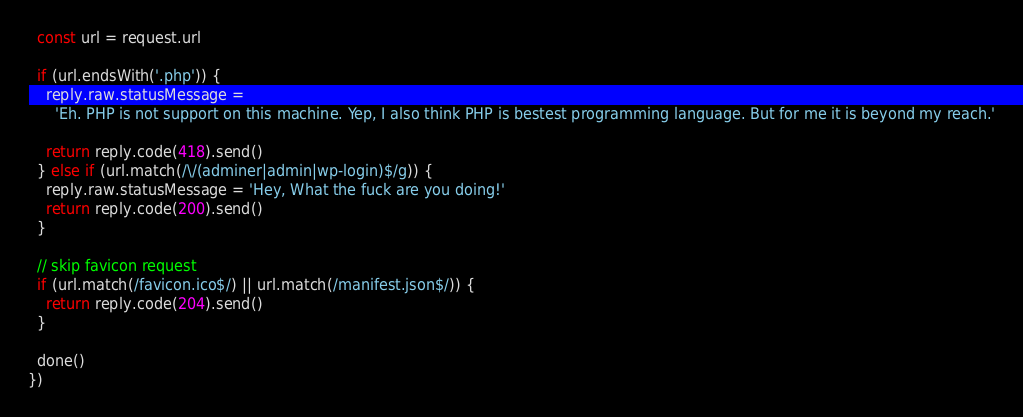<code> <loc_0><loc_0><loc_500><loc_500><_TypeScript_>  const url = request.url

  if (url.endsWith('.php')) {
    reply.raw.statusMessage =
      'Eh. PHP is not support on this machine. Yep, I also think PHP is bestest programming language. But for me it is beyond my reach.'

    return reply.code(418).send()
  } else if (url.match(/\/(adminer|admin|wp-login)$/g)) {
    reply.raw.statusMessage = 'Hey, What the fuck are you doing!'
    return reply.code(200).send()
  }

  // skip favicon request
  if (url.match(/favicon.ico$/) || url.match(/manifest.json$/)) {
    return reply.code(204).send()
  }

  done()
})
</code> 